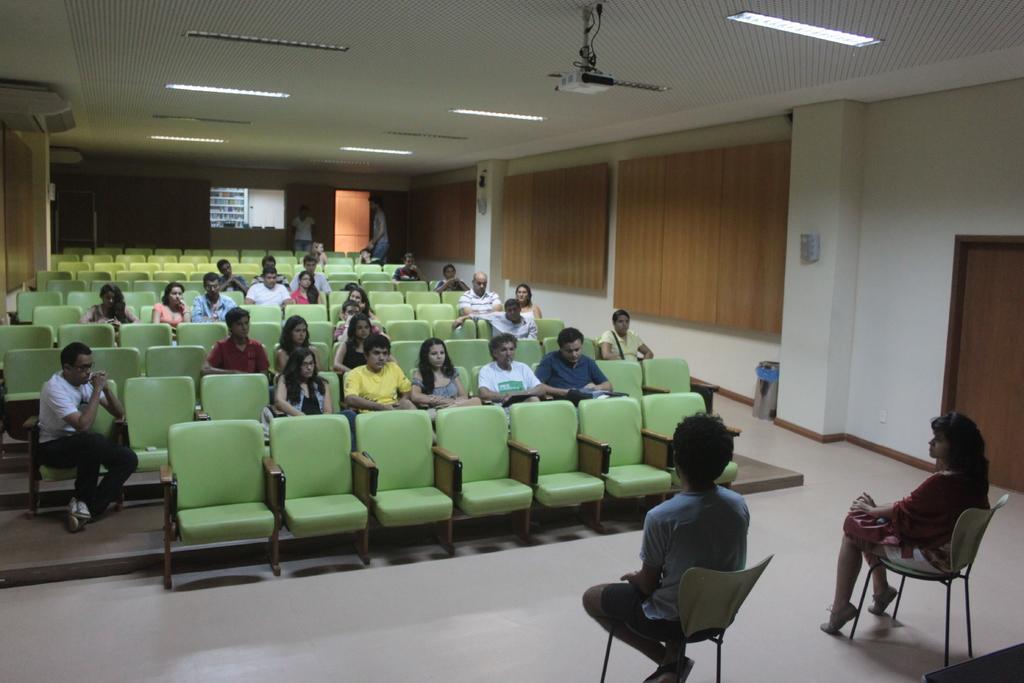How would you summarize this image in a sentence or two? This picture of inside the hall. In the foreground there is a woman and a man sitting on the chairs. In the center there are many number of chairs and there are group of people sitting on the chairs. On the top there is a roof, projector and ceiling lights. In the background we can see a door and persons seems to be standing and a wall and a shelf. 